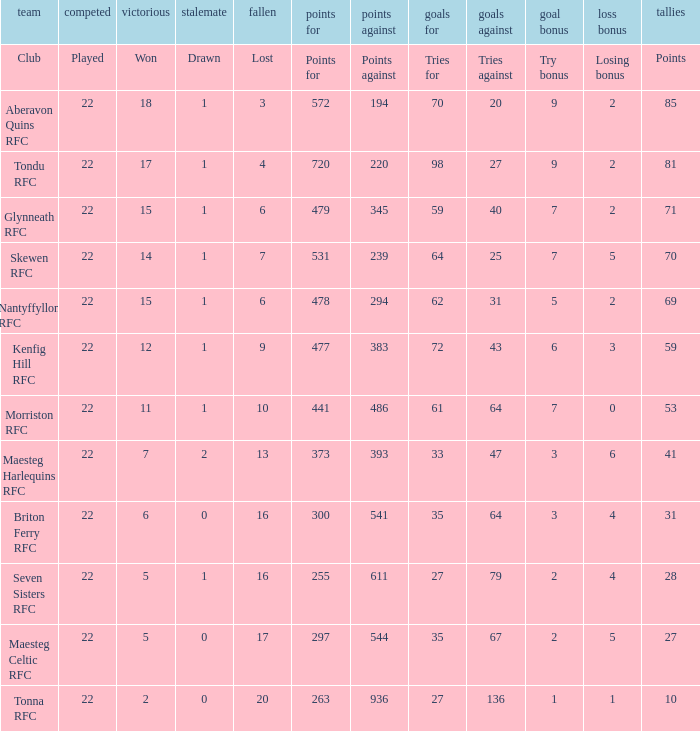What club got 239 points against? Skewen RFC. 